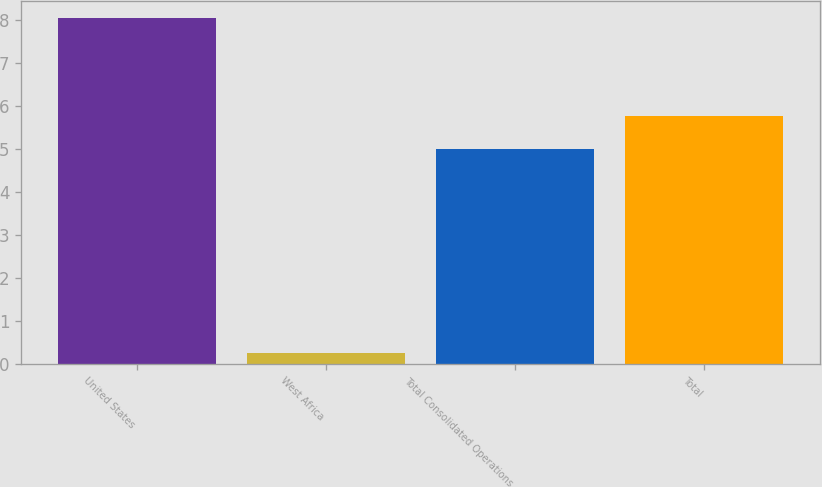Convert chart. <chart><loc_0><loc_0><loc_500><loc_500><bar_chart><fcel>United States<fcel>West Africa<fcel>Total Consolidated Operations<fcel>Total<nl><fcel>8.05<fcel>0.27<fcel>5<fcel>5.78<nl></chart> 